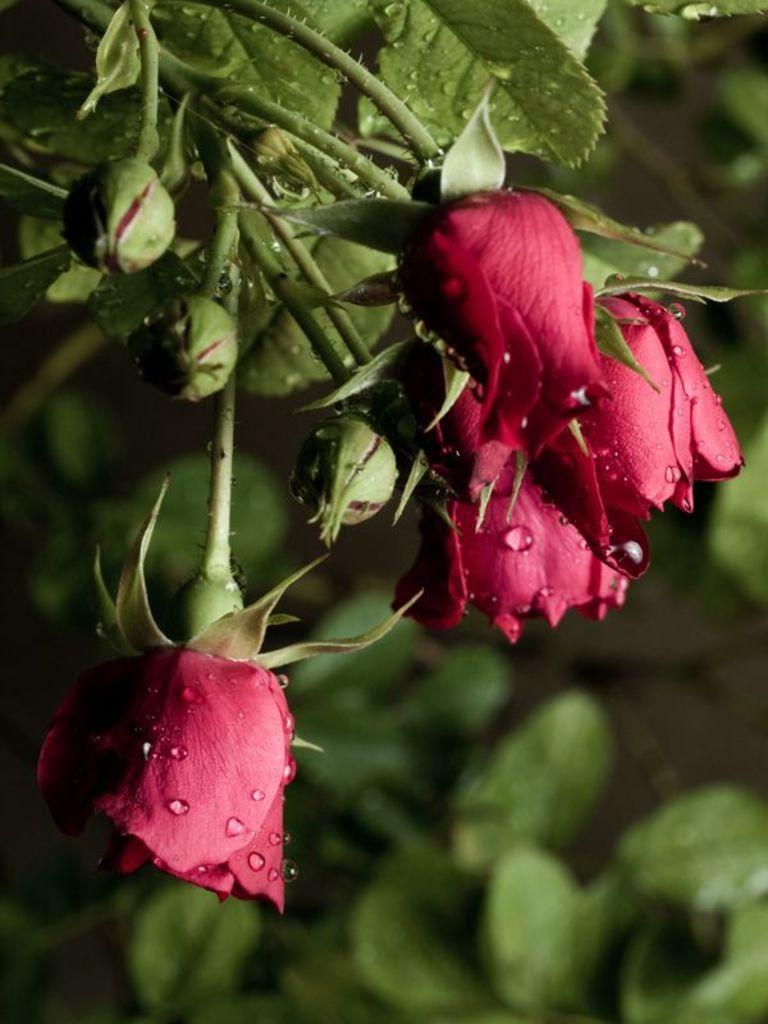In one or two sentences, can you explain what this image depicts? In this image, we can see flowers, buds and leaves. In the background, image is blurred. 